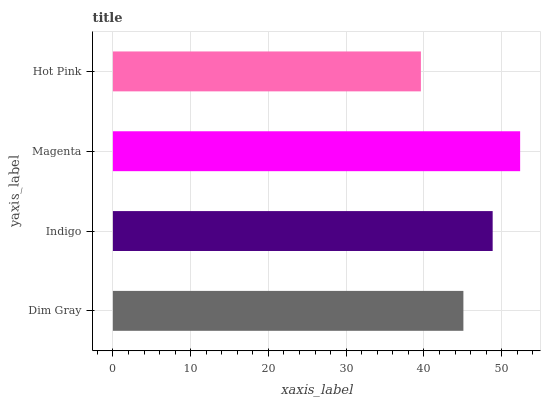Is Hot Pink the minimum?
Answer yes or no. Yes. Is Magenta the maximum?
Answer yes or no. Yes. Is Indigo the minimum?
Answer yes or no. No. Is Indigo the maximum?
Answer yes or no. No. Is Indigo greater than Dim Gray?
Answer yes or no. Yes. Is Dim Gray less than Indigo?
Answer yes or no. Yes. Is Dim Gray greater than Indigo?
Answer yes or no. No. Is Indigo less than Dim Gray?
Answer yes or no. No. Is Indigo the high median?
Answer yes or no. Yes. Is Dim Gray the low median?
Answer yes or no. Yes. Is Hot Pink the high median?
Answer yes or no. No. Is Magenta the low median?
Answer yes or no. No. 